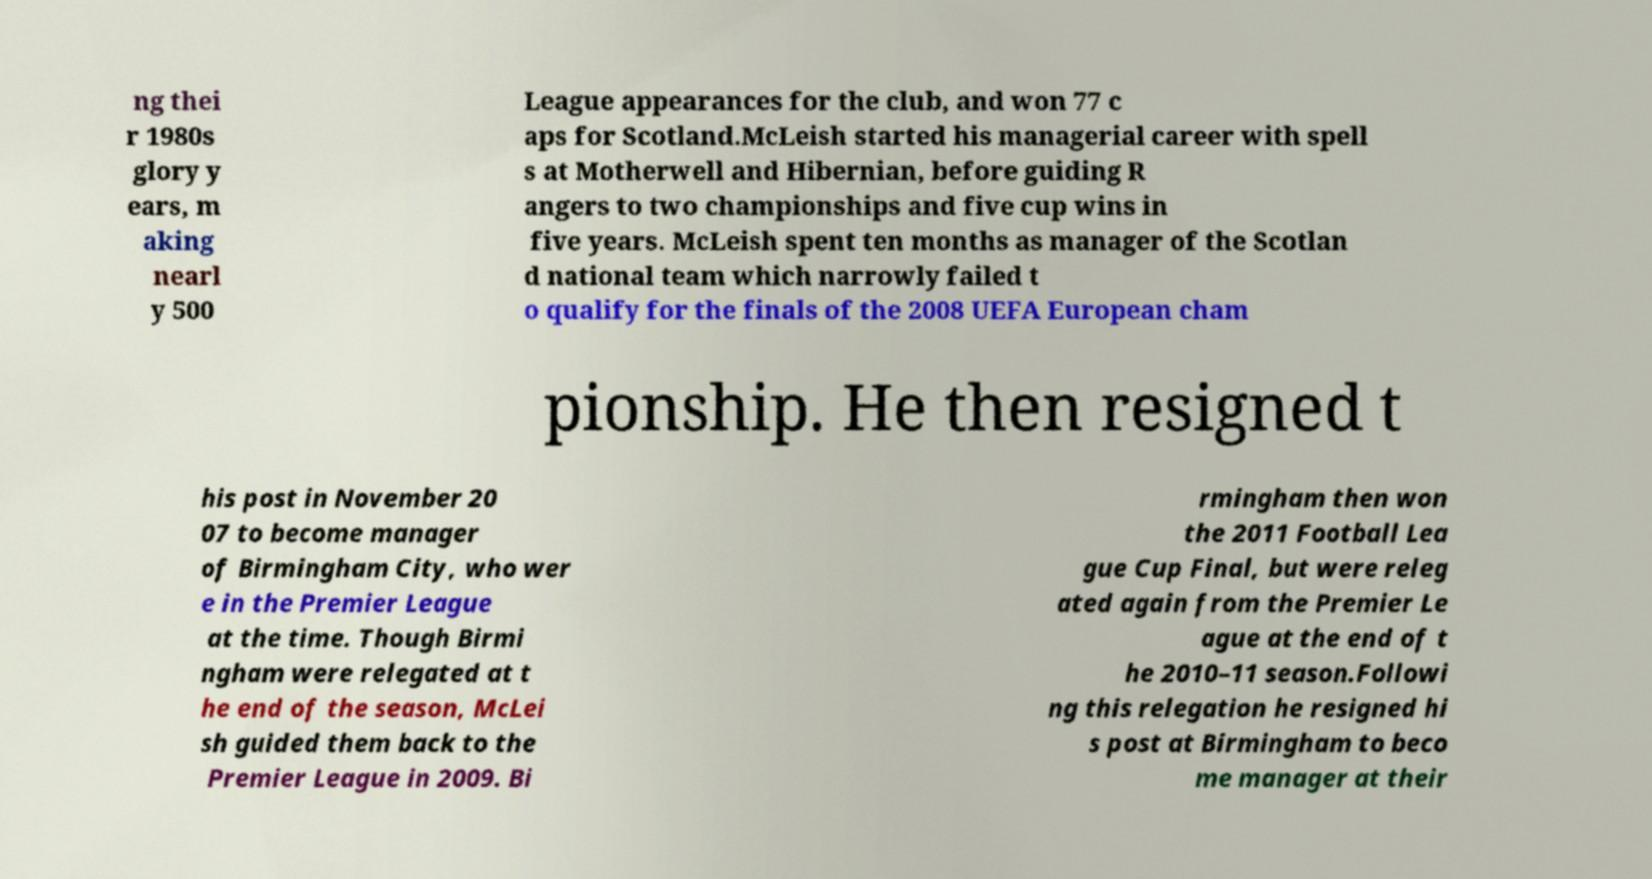Can you accurately transcribe the text from the provided image for me? ng thei r 1980s glory y ears, m aking nearl y 500 League appearances for the club, and won 77 c aps for Scotland.McLeish started his managerial career with spell s at Motherwell and Hibernian, before guiding R angers to two championships and five cup wins in five years. McLeish spent ten months as manager of the Scotlan d national team which narrowly failed t o qualify for the finals of the 2008 UEFA European cham pionship. He then resigned t his post in November 20 07 to become manager of Birmingham City, who wer e in the Premier League at the time. Though Birmi ngham were relegated at t he end of the season, McLei sh guided them back to the Premier League in 2009. Bi rmingham then won the 2011 Football Lea gue Cup Final, but were releg ated again from the Premier Le ague at the end of t he 2010–11 season.Followi ng this relegation he resigned hi s post at Birmingham to beco me manager at their 